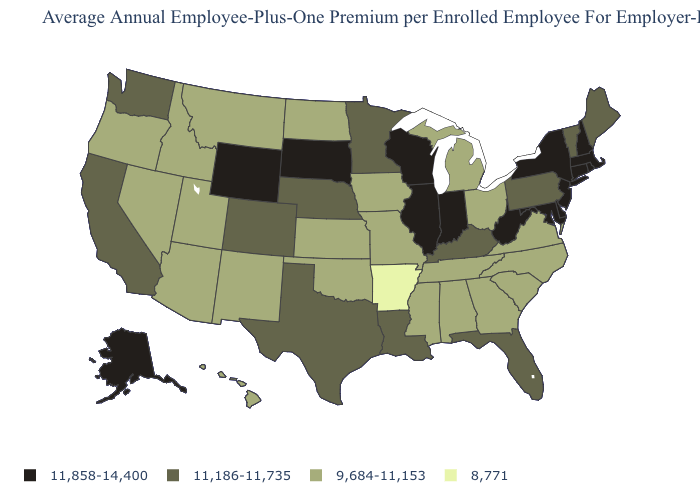Does Oregon have the lowest value in the USA?
Be succinct. No. Name the states that have a value in the range 8,771?
Keep it brief. Arkansas. What is the value of Colorado?
Keep it brief. 11,186-11,735. What is the value of Tennessee?
Concise answer only. 9,684-11,153. Which states have the lowest value in the USA?
Short answer required. Arkansas. Among the states that border Indiana , which have the lowest value?
Short answer required. Michigan, Ohio. Among the states that border Georgia , which have the highest value?
Concise answer only. Florida. Among the states that border New Hampshire , does Massachusetts have the lowest value?
Give a very brief answer. No. Is the legend a continuous bar?
Give a very brief answer. No. What is the value of Utah?
Write a very short answer. 9,684-11,153. What is the value of Oregon?
Concise answer only. 9,684-11,153. Name the states that have a value in the range 8,771?
Write a very short answer. Arkansas. Among the states that border Wisconsin , which have the lowest value?
Be succinct. Iowa, Michigan. Does the first symbol in the legend represent the smallest category?
Give a very brief answer. No. Among the states that border Ohio , which have the lowest value?
Be succinct. Michigan. 